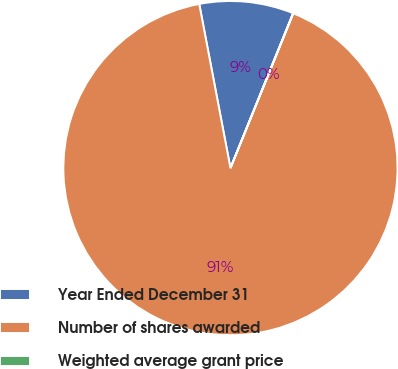<chart> <loc_0><loc_0><loc_500><loc_500><pie_chart><fcel>Year Ended December 31<fcel>Number of shares awarded<fcel>Weighted average grant price<nl><fcel>9.11%<fcel>90.87%<fcel>0.02%<nl></chart> 